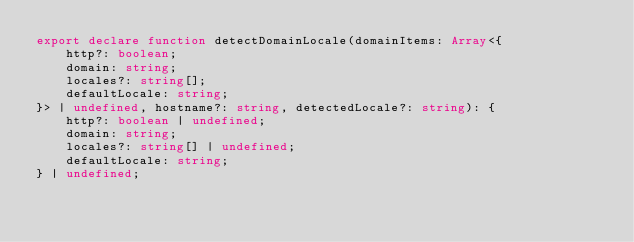Convert code to text. <code><loc_0><loc_0><loc_500><loc_500><_TypeScript_>export declare function detectDomainLocale(domainItems: Array<{
    http?: boolean;
    domain: string;
    locales?: string[];
    defaultLocale: string;
}> | undefined, hostname?: string, detectedLocale?: string): {
    http?: boolean | undefined;
    domain: string;
    locales?: string[] | undefined;
    defaultLocale: string;
} | undefined;
</code> 